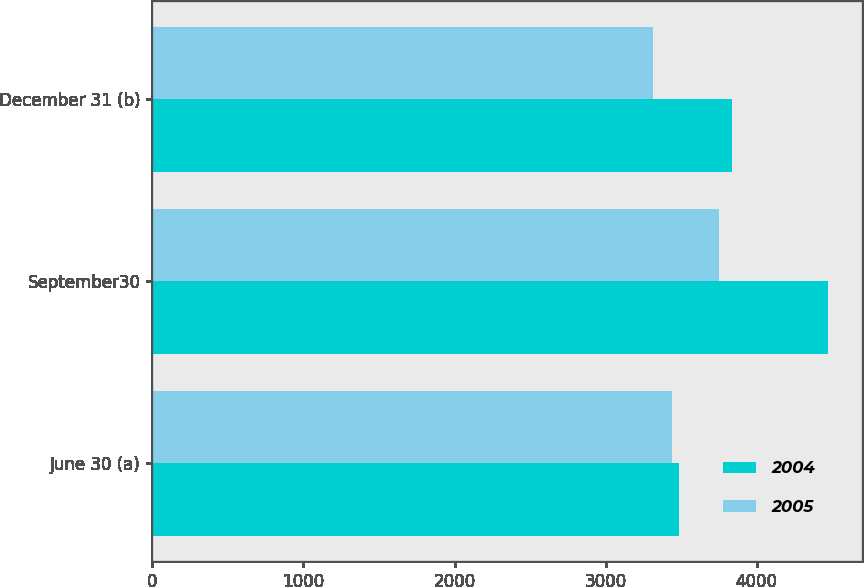Convert chart to OTSL. <chart><loc_0><loc_0><loc_500><loc_500><stacked_bar_chart><ecel><fcel>June 30 (a)<fcel>September30<fcel>December 31 (b)<nl><fcel>2004<fcel>3484<fcel>4473<fcel>3838<nl><fcel>2005<fcel>3438<fcel>3748<fcel>3312<nl></chart> 